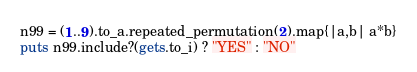Convert code to text. <code><loc_0><loc_0><loc_500><loc_500><_Ruby_>n99 = (1..9).to_a.repeated_permutation(2).map{|a,b| a*b}
puts n99.include?(gets.to_i) ? "YES" : "NO"</code> 